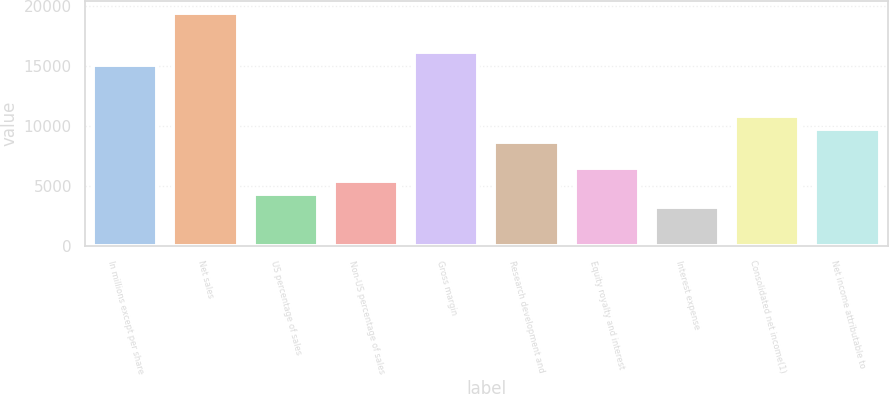Convert chart to OTSL. <chart><loc_0><loc_0><loc_500><loc_500><bar_chart><fcel>In millions except per share<fcel>Net sales<fcel>US percentage of sales<fcel>Non-US percentage of sales<fcel>Gross margin<fcel>Research development and<fcel>Equity royalty and interest<fcel>Interest expense<fcel>Consolidated net income(1)<fcel>Net income attributable to<nl><fcel>15119.7<fcel>19439.4<fcel>4320.42<fcel>5400.35<fcel>16199.6<fcel>8640.14<fcel>6480.28<fcel>3240.49<fcel>10800<fcel>9720.07<nl></chart> 